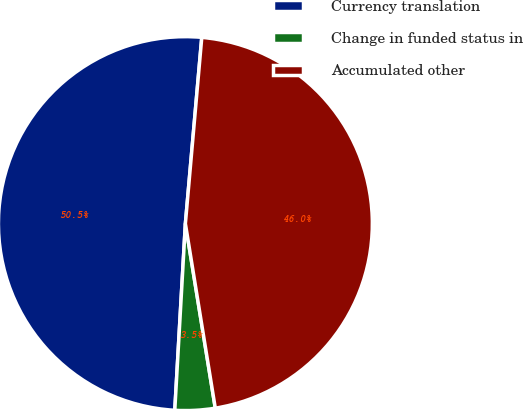Convert chart. <chart><loc_0><loc_0><loc_500><loc_500><pie_chart><fcel>Currency translation<fcel>Change in funded status in<fcel>Accumulated other<nl><fcel>50.49%<fcel>3.46%<fcel>46.04%<nl></chart> 